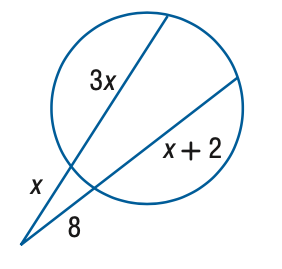Answer the mathemtical geometry problem and directly provide the correct option letter.
Question: Find x to the nearest tenth. 
Choices: A: 4 B: 5.6 C: 6 D: 8 B 